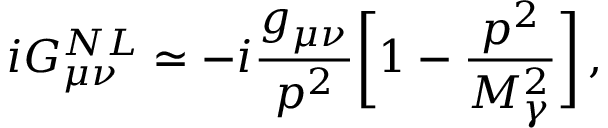<formula> <loc_0><loc_0><loc_500><loc_500>i G _ { \mu \nu } ^ { N L } \simeq - i \frac { g _ { \mu \nu } } { p ^ { 2 } } \left [ 1 - \frac { p ^ { 2 } } { M _ { \gamma } ^ { 2 } } \right ] \, ,</formula> 